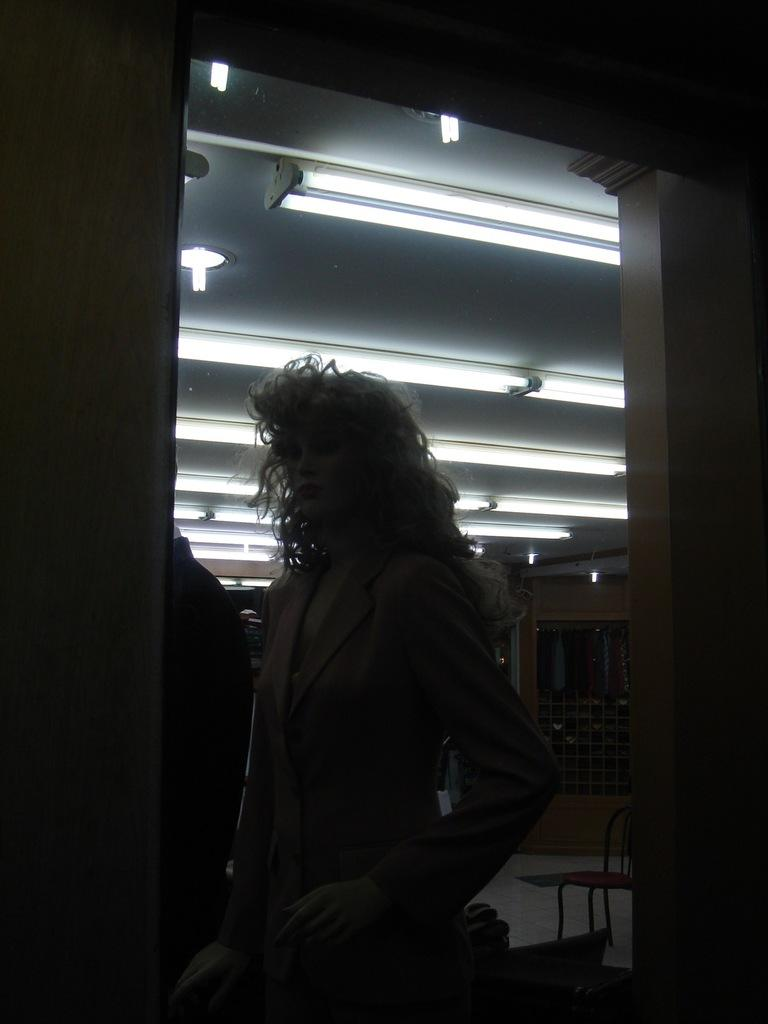What is located in the foreground of the image? A: There is a mannequin in the foreground of the image. What can be seen on the left and top sides of the image? There is a wall on the left and top sides of the image. What is visible on the ceiling in the background? There are lights on the ceiling in the background. What type of furniture is present on the floor in the background? There is a chair on the floor in the background. What color is the goose that is pushing the chair in the image? There is no goose present in the image, nor is there any indication of a goose pushing a chair. 